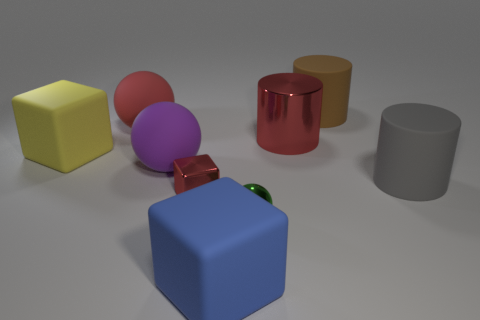Subtract all large rubber blocks. How many blocks are left? 1 Subtract 2 cubes. How many cubes are left? 1 Subtract all purple spheres. How many spheres are left? 2 Subtract all cylinders. How many objects are left? 6 Add 4 big purple matte balls. How many big purple matte balls exist? 5 Subtract 1 purple balls. How many objects are left? 8 Subtract all yellow blocks. Subtract all yellow cylinders. How many blocks are left? 2 Subtract all small balls. Subtract all purple matte spheres. How many objects are left? 7 Add 3 small green metallic objects. How many small green metallic objects are left? 4 